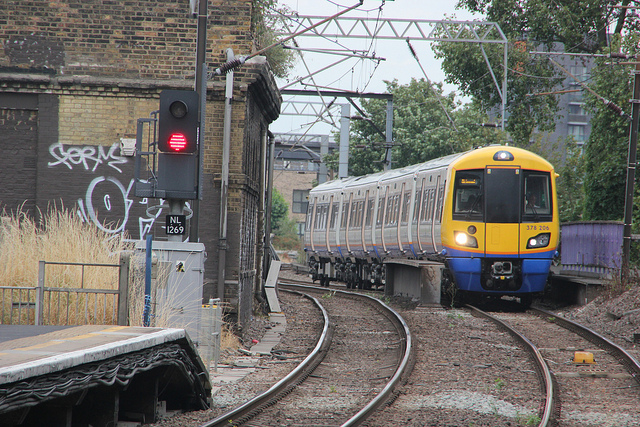Identify the text displayed in this image. NL 1269 0 